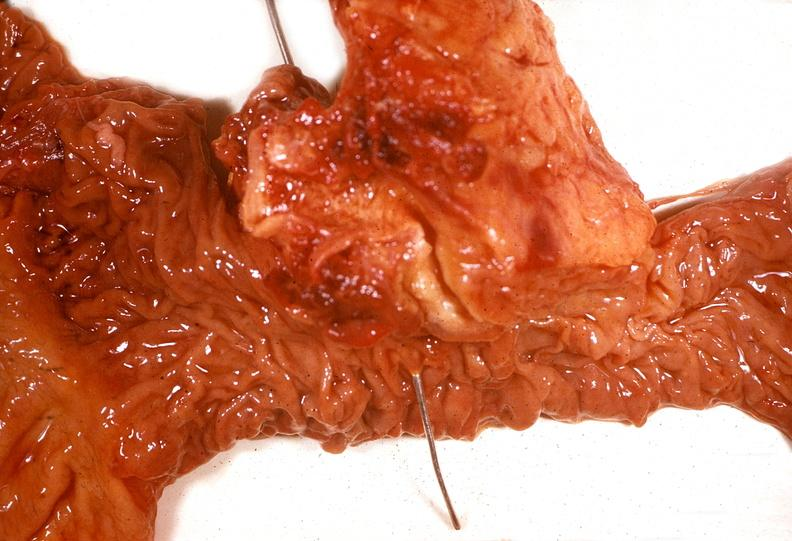does this image show adenocarcinoma, head of pancreas?
Answer the question using a single word or phrase. Yes 